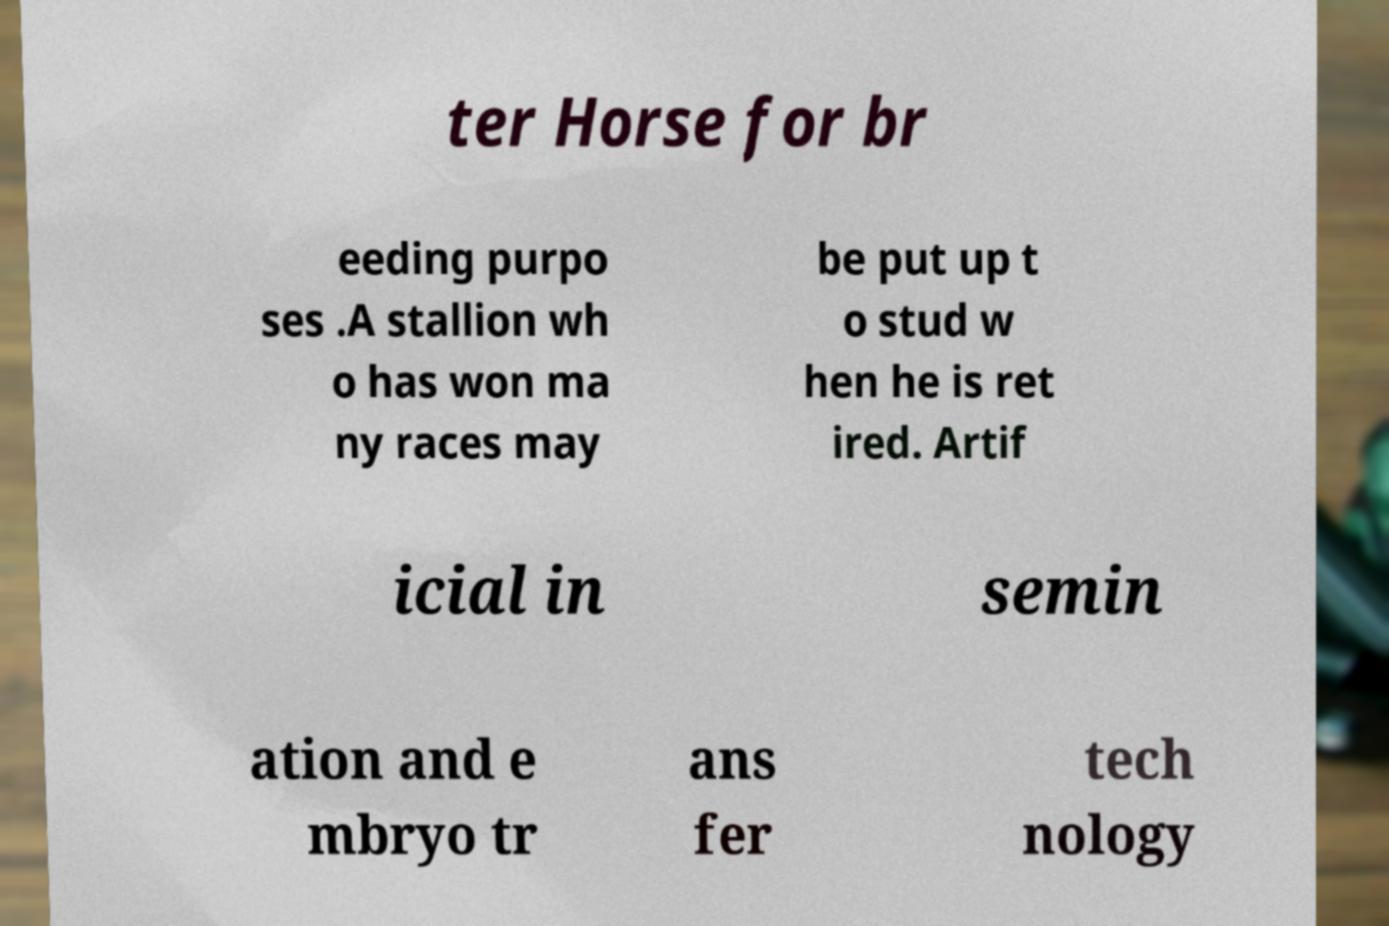Could you assist in decoding the text presented in this image and type it out clearly? ter Horse for br eeding purpo ses .A stallion wh o has won ma ny races may be put up t o stud w hen he is ret ired. Artif icial in semin ation and e mbryo tr ans fer tech nology 